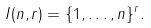<formula> <loc_0><loc_0><loc_500><loc_500>I ( n , r ) = \{ 1 , \dots , n \} ^ { r } .</formula> 